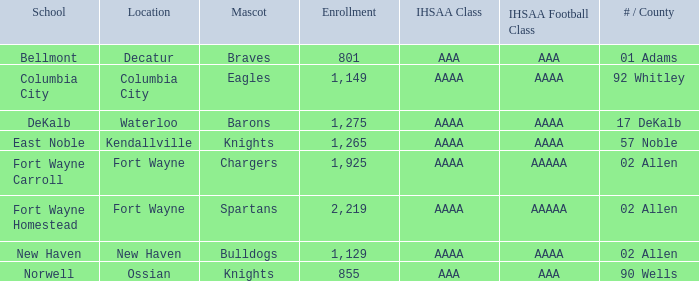What school has a mascot of the spartans with an AAAA IHSAA class and more than 1,275 enrolled? Fort Wayne Homestead. 